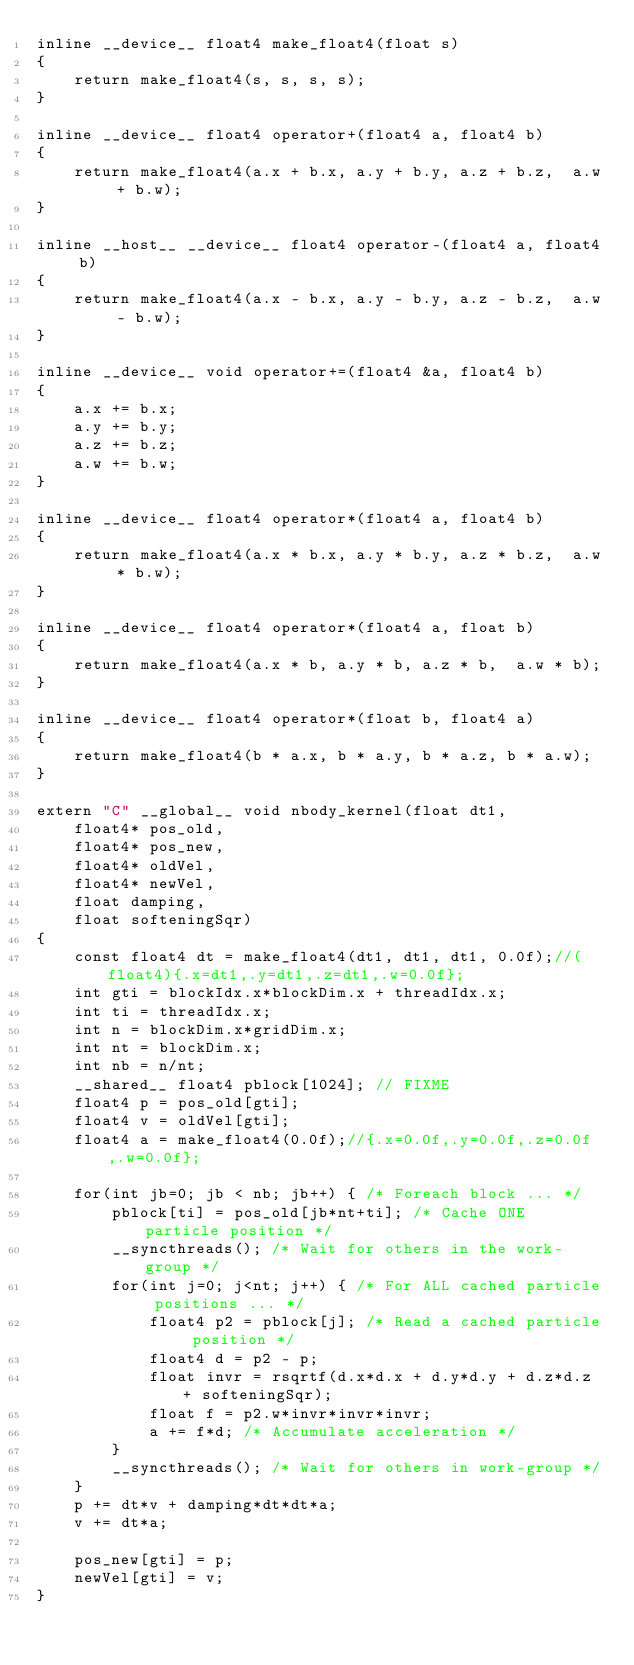Convert code to text. <code><loc_0><loc_0><loc_500><loc_500><_Cuda_>inline __device__ float4 make_float4(float s)
{
    return make_float4(s, s, s, s);
}

inline __device__ float4 operator+(float4 a, float4 b)
{
    return make_float4(a.x + b.x, a.y + b.y, a.z + b.z,  a.w + b.w);
}

inline __host__ __device__ float4 operator-(float4 a, float4 b)
{
    return make_float4(a.x - b.x, a.y - b.y, a.z - b.z,  a.w - b.w);
}

inline __device__ void operator+=(float4 &a, float4 b)
{
    a.x += b.x;
    a.y += b.y;
    a.z += b.z;
    a.w += b.w;
}

inline __device__ float4 operator*(float4 a, float4 b)
{
    return make_float4(a.x * b.x, a.y * b.y, a.z * b.z,  a.w * b.w);
}

inline __device__ float4 operator*(float4 a, float b)
{
    return make_float4(a.x * b, a.y * b, a.z * b,  a.w * b);
}

inline __device__ float4 operator*(float b, float4 a)
{
    return make_float4(b * a.x, b * a.y, b * a.z, b * a.w);
}

extern "C" __global__ void nbody_kernel(float dt1,
	float4* pos_old, 
	float4* pos_new,
	float4* oldVel,
	float4* newVel,
	float damping, 
	float softeningSqr)
{
	const float4 dt = make_float4(dt1, dt1, dt1, 0.0f);//(float4){.x=dt1,.y=dt1,.z=dt1,.w=0.0f};
	int gti = blockIdx.x*blockDim.x + threadIdx.x;
	int ti = threadIdx.x;
	int n = blockDim.x*gridDim.x;
	int nt = blockDim.x;
	int nb = n/nt;
	__shared__ float4 pblock[1024]; // FIXME
	float4 p = pos_old[gti];
	float4 v = oldVel[gti];
	float4 a = make_float4(0.0f);//{.x=0.0f,.y=0.0f,.z=0.0f,.w=0.0f};
	
	for(int jb=0; jb < nb; jb++) { /* Foreach block ... */
		pblock[ti] = pos_old[jb*nt+ti]; /* Cache ONE particle position */
		__syncthreads(); /* Wait for others in the work-group */
		for(int j=0; j<nt; j++) { /* For ALL cached particle positions ... */
			float4 p2 = pblock[j]; /* Read a cached particle position */
			float4 d = p2 - p;
			float invr = rsqrtf(d.x*d.x + d.y*d.y + d.z*d.z + softeningSqr);
			float f = p2.w*invr*invr*invr;
			a += f*d; /* Accumulate acceleration */
		}
		__syncthreads(); /* Wait for others in work-group */
	}
	p += dt*v + damping*dt*dt*a;
	v += dt*a;

	pos_new[gti] = p;
	newVel[gti] = v;
}

</code> 